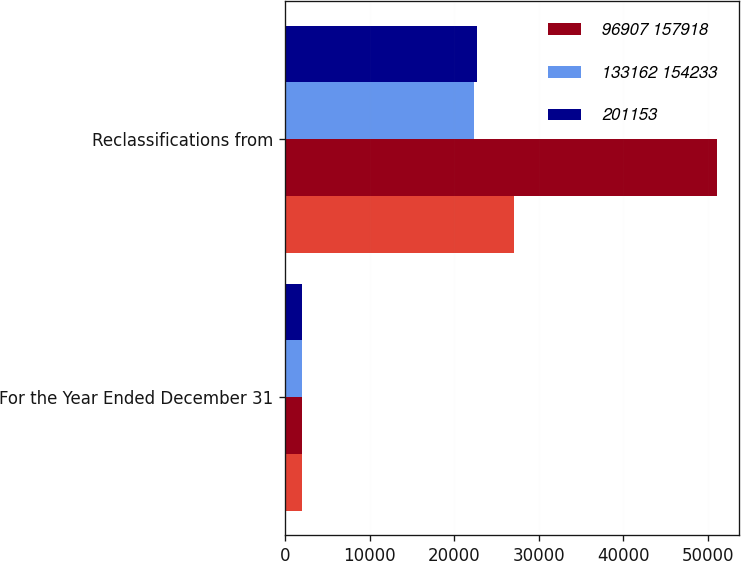Convert chart to OTSL. <chart><loc_0><loc_0><loc_500><loc_500><stacked_bar_chart><ecel><fcel>For the Year Ended December 31<fcel>Reclassifications from<nl><fcel>nan<fcel>2018<fcel>27111<nl><fcel>96907 157918<fcel>2017<fcel>51137<nl><fcel>133162 154233<fcel>2016<fcel>22384<nl><fcel>201153<fcel>2016<fcel>22677<nl></chart> 